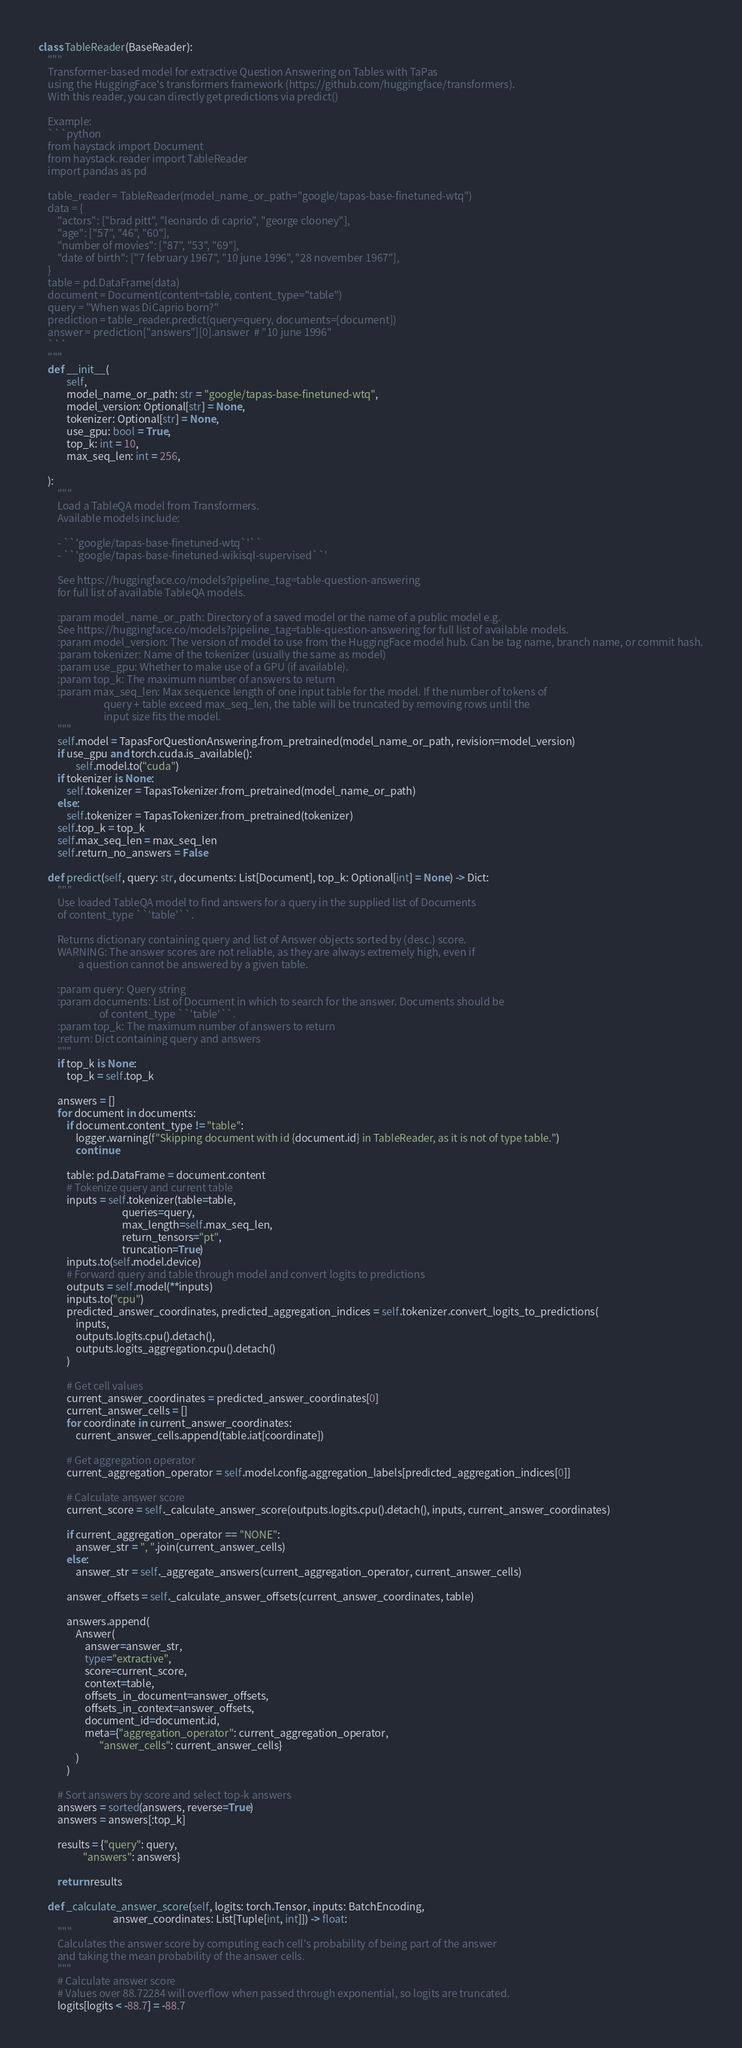Convert code to text. <code><loc_0><loc_0><loc_500><loc_500><_Python_>
class TableReader(BaseReader):
    """
    Transformer-based model for extractive Question Answering on Tables with TaPas
    using the HuggingFace's transformers framework (https://github.com/huggingface/transformers).
    With this reader, you can directly get predictions via predict()

    Example:
    ```python
    from haystack import Document
    from haystack.reader import TableReader
    import pandas as pd

    table_reader = TableReader(model_name_or_path="google/tapas-base-finetuned-wtq")
    data = {
        "actors": ["brad pitt", "leonardo di caprio", "george clooney"],
        "age": ["57", "46", "60"],
        "number of movies": ["87", "53", "69"],
        "date of birth": ["7 february 1967", "10 june 1996", "28 november 1967"],
    }
    table = pd.DataFrame(data)
    document = Document(content=table, content_type="table")
    query = "When was DiCaprio born?"
    prediction = table_reader.predict(query=query, documents=[document])
    answer = prediction["answers"][0].answer  # "10 june 1996"
    ```
    """
    def __init__(
            self,
            model_name_or_path: str = "google/tapas-base-finetuned-wtq",
            model_version: Optional[str] = None,
            tokenizer: Optional[str] = None,
            use_gpu: bool = True,
            top_k: int = 10,
            max_seq_len: int = 256,

    ):
        """
        Load a TableQA model from Transformers.
        Available models include:

        - ``'google/tapas-base-finetuned-wtq`'``
        - ``'google/tapas-base-finetuned-wikisql-supervised``'

        See https://huggingface.co/models?pipeline_tag=table-question-answering
        for full list of available TableQA models.

        :param model_name_or_path: Directory of a saved model or the name of a public model e.g.
        See https://huggingface.co/models?pipeline_tag=table-question-answering for full list of available models.
        :param model_version: The version of model to use from the HuggingFace model hub. Can be tag name, branch name, or commit hash.
        :param tokenizer: Name of the tokenizer (usually the same as model)
        :param use_gpu: Whether to make use of a GPU (if available).
        :param top_k: The maximum number of answers to return
        :param max_seq_len: Max sequence length of one input table for the model. If the number of tokens of
                            query + table exceed max_seq_len, the table will be truncated by removing rows until the
                            input size fits the model.
        """
        self.model = TapasForQuestionAnswering.from_pretrained(model_name_or_path, revision=model_version)
        if use_gpu and torch.cuda.is_available():
                self.model.to("cuda")
        if tokenizer is None:
            self.tokenizer = TapasTokenizer.from_pretrained(model_name_or_path)
        else:
            self.tokenizer = TapasTokenizer.from_pretrained(tokenizer)
        self.top_k = top_k
        self.max_seq_len = max_seq_len
        self.return_no_answers = False

    def predict(self, query: str, documents: List[Document], top_k: Optional[int] = None) -> Dict:
        """
        Use loaded TableQA model to find answers for a query in the supplied list of Documents
        of content_type ``'table'``.

        Returns dictionary containing query and list of Answer objects sorted by (desc.) score.
        WARNING: The answer scores are not reliable, as they are always extremely high, even if
                 a question cannot be answered by a given table.

        :param query: Query string
        :param documents: List of Document in which to search for the answer. Documents should be
                          of content_type ``'table'``.
        :param top_k: The maximum number of answers to return
        :return: Dict containing query and answers
        """
        if top_k is None:
            top_k = self.top_k

        answers = []
        for document in documents:
            if document.content_type != "table":
                logger.warning(f"Skipping document with id {document.id} in TableReader, as it is not of type table.")
                continue

            table: pd.DataFrame = document.content
            # Tokenize query and current table
            inputs = self.tokenizer(table=table,
                                    queries=query,
                                    max_length=self.max_seq_len,
                                    return_tensors="pt",
                                    truncation=True)
            inputs.to(self.model.device)
            # Forward query and table through model and convert logits to predictions
            outputs = self.model(**inputs)
            inputs.to("cpu")
            predicted_answer_coordinates, predicted_aggregation_indices = self.tokenizer.convert_logits_to_predictions(
                inputs,
                outputs.logits.cpu().detach(),
                outputs.logits_aggregation.cpu().detach()
            )

            # Get cell values
            current_answer_coordinates = predicted_answer_coordinates[0]
            current_answer_cells = []
            for coordinate in current_answer_coordinates:
                current_answer_cells.append(table.iat[coordinate])

            # Get aggregation operator
            current_aggregation_operator = self.model.config.aggregation_labels[predicted_aggregation_indices[0]]
            
            # Calculate answer score
            current_score = self._calculate_answer_score(outputs.logits.cpu().detach(), inputs, current_answer_coordinates)

            if current_aggregation_operator == "NONE":
                answer_str = ", ".join(current_answer_cells)
            else:
                answer_str = self._aggregate_answers(current_aggregation_operator, current_answer_cells)

            answer_offsets = self._calculate_answer_offsets(current_answer_coordinates, table)

            answers.append(
                Answer(
                    answer=answer_str,
                    type="extractive",
                    score=current_score,
                    context=table,
                    offsets_in_document=answer_offsets,
                    offsets_in_context=answer_offsets,
                    document_id=document.id,
                    meta={"aggregation_operator": current_aggregation_operator,
                          "answer_cells": current_answer_cells}
                )
            )

        # Sort answers by score and select top-k answers
        answers = sorted(answers, reverse=True)
        answers = answers[:top_k]

        results = {"query": query,
                   "answers": answers}

        return results
    
    def _calculate_answer_score(self, logits: torch.Tensor, inputs: BatchEncoding,
                                answer_coordinates: List[Tuple[int, int]]) -> float:
        """
        Calculates the answer score by computing each cell's probability of being part of the answer
        and taking the mean probability of the answer cells.
        """
        # Calculate answer score
        # Values over 88.72284 will overflow when passed through exponential, so logits are truncated.
        logits[logits < -88.7] = -88.7</code> 